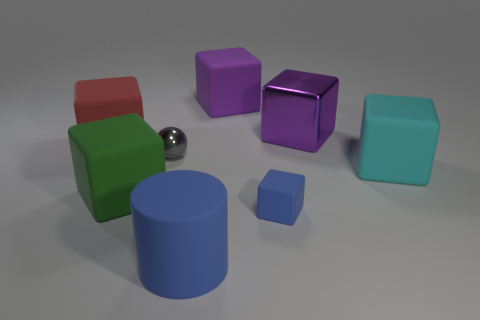How many cylinders are small blue matte things or cyan objects?
Your response must be concise. 0. The other shiny object that is the same size as the cyan object is what color?
Your answer should be compact. Purple. Are there any big rubber things to the right of the big matte block behind the metallic thing on the right side of the small matte cube?
Offer a very short reply. Yes. What size is the gray shiny sphere?
Offer a very short reply. Small. What number of things are gray metal things or cyan metallic cubes?
Keep it short and to the point. 1. There is a tiny thing that is made of the same material as the large blue cylinder; what is its color?
Your answer should be very brief. Blue. Do the big object to the left of the large green cube and the small gray object have the same shape?
Make the answer very short. No. How many things are big matte cubes that are on the right side of the green matte object or large metallic cubes to the right of the tiny blue rubber cube?
Provide a short and direct response. 3. What is the color of the small matte thing that is the same shape as the big cyan object?
Keep it short and to the point. Blue. Is there anything else that is the same shape as the tiny metallic thing?
Make the answer very short. No. 